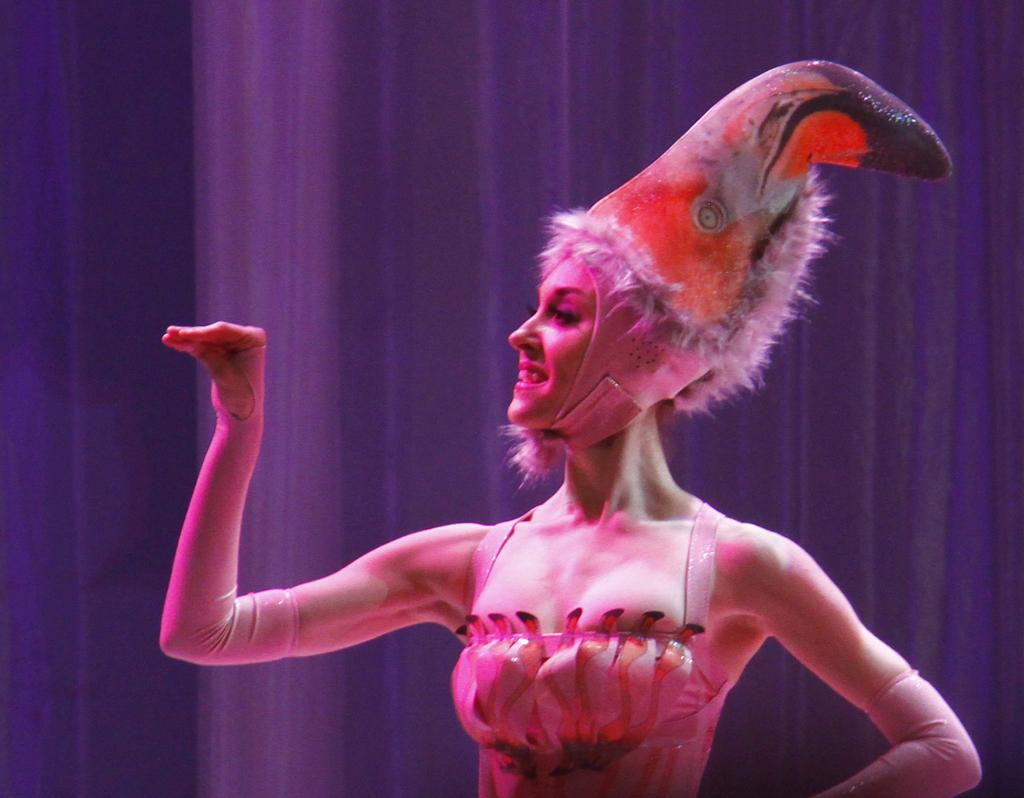What is the main subject of the image? The main subject of the image is a woman. What is the woman wearing in the image? The woman is wearing a different costume and a headgear. What color are the curtains in the background of the image? The curtains in the background of the image are purple. How many chickens are present in the image? There are no chickens present in the image; it features a woman wearing a different costume and headgear with purple curtains in the background. 